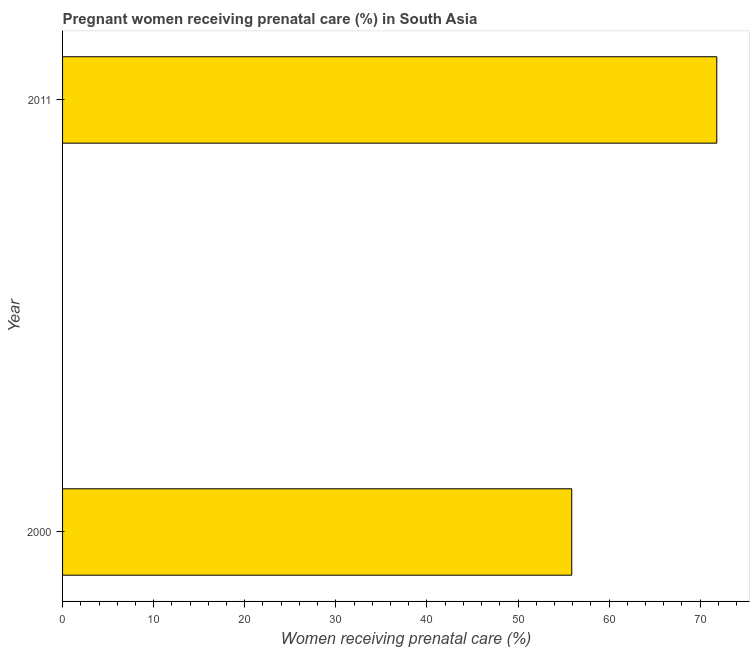Does the graph contain any zero values?
Offer a very short reply. No. What is the title of the graph?
Your answer should be very brief. Pregnant women receiving prenatal care (%) in South Asia. What is the label or title of the X-axis?
Offer a very short reply. Women receiving prenatal care (%). What is the percentage of pregnant women receiving prenatal care in 2000?
Your answer should be compact. 55.9. Across all years, what is the maximum percentage of pregnant women receiving prenatal care?
Keep it short and to the point. 71.82. Across all years, what is the minimum percentage of pregnant women receiving prenatal care?
Your answer should be compact. 55.9. In which year was the percentage of pregnant women receiving prenatal care maximum?
Offer a terse response. 2011. In which year was the percentage of pregnant women receiving prenatal care minimum?
Your answer should be very brief. 2000. What is the sum of the percentage of pregnant women receiving prenatal care?
Give a very brief answer. 127.72. What is the difference between the percentage of pregnant women receiving prenatal care in 2000 and 2011?
Make the answer very short. -15.92. What is the average percentage of pregnant women receiving prenatal care per year?
Ensure brevity in your answer.  63.86. What is the median percentage of pregnant women receiving prenatal care?
Offer a terse response. 63.86. In how many years, is the percentage of pregnant women receiving prenatal care greater than 44 %?
Make the answer very short. 2. Do a majority of the years between 2000 and 2011 (inclusive) have percentage of pregnant women receiving prenatal care greater than 14 %?
Make the answer very short. Yes. What is the ratio of the percentage of pregnant women receiving prenatal care in 2000 to that in 2011?
Provide a short and direct response. 0.78. Is the percentage of pregnant women receiving prenatal care in 2000 less than that in 2011?
Provide a short and direct response. Yes. In how many years, is the percentage of pregnant women receiving prenatal care greater than the average percentage of pregnant women receiving prenatal care taken over all years?
Provide a succinct answer. 1. How many bars are there?
Make the answer very short. 2. How many years are there in the graph?
Offer a terse response. 2. What is the difference between two consecutive major ticks on the X-axis?
Provide a succinct answer. 10. Are the values on the major ticks of X-axis written in scientific E-notation?
Your answer should be compact. No. What is the Women receiving prenatal care (%) of 2000?
Make the answer very short. 55.9. What is the Women receiving prenatal care (%) in 2011?
Ensure brevity in your answer.  71.82. What is the difference between the Women receiving prenatal care (%) in 2000 and 2011?
Ensure brevity in your answer.  -15.92. What is the ratio of the Women receiving prenatal care (%) in 2000 to that in 2011?
Make the answer very short. 0.78. 